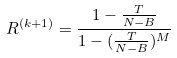<formula> <loc_0><loc_0><loc_500><loc_500>R ^ { ( k + 1 ) } = \frac { 1 - \frac { T } { N - B } } { 1 - ( \frac { T } { N - B } ) ^ { M } }</formula> 